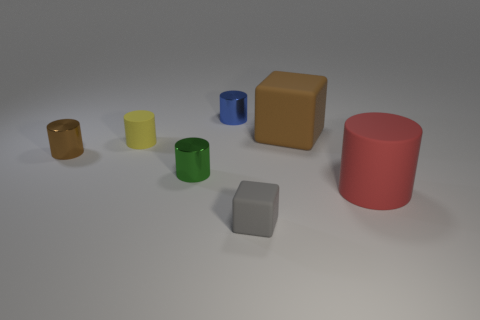Subtract all yellow cylinders. How many cylinders are left? 4 Subtract all big red cylinders. How many cylinders are left? 4 Subtract all purple cylinders. Subtract all purple cubes. How many cylinders are left? 5 Add 2 tiny gray shiny cubes. How many objects exist? 9 Subtract all blocks. How many objects are left? 5 Add 3 large things. How many large things exist? 5 Subtract 1 brown cylinders. How many objects are left? 6 Subtract all gray cylinders. Subtract all gray matte cubes. How many objects are left? 6 Add 3 cubes. How many cubes are left? 5 